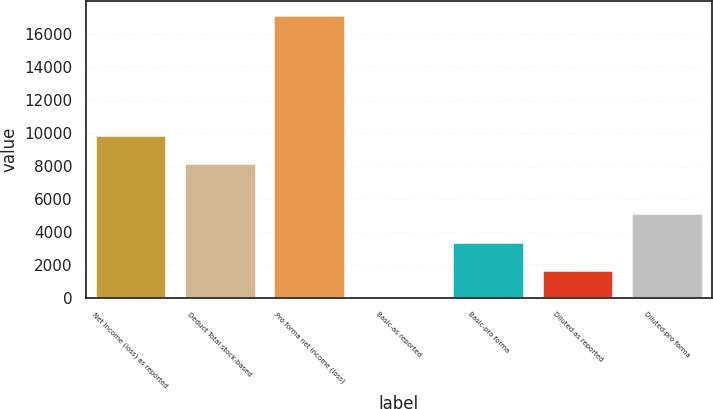Convert chart. <chart><loc_0><loc_0><loc_500><loc_500><bar_chart><fcel>Net income (loss) as reported<fcel>Deduct Total stock-based<fcel>Pro forma net income (loss)<fcel>Basic-as reported<fcel>Basic-pro forma<fcel>Diluted-as reported<fcel>Diluted-pro forma<nl><fcel>9885.86<fcel>8176<fcel>17099<fcel>0.41<fcel>3420.13<fcel>1710.27<fcel>5129.99<nl></chart> 